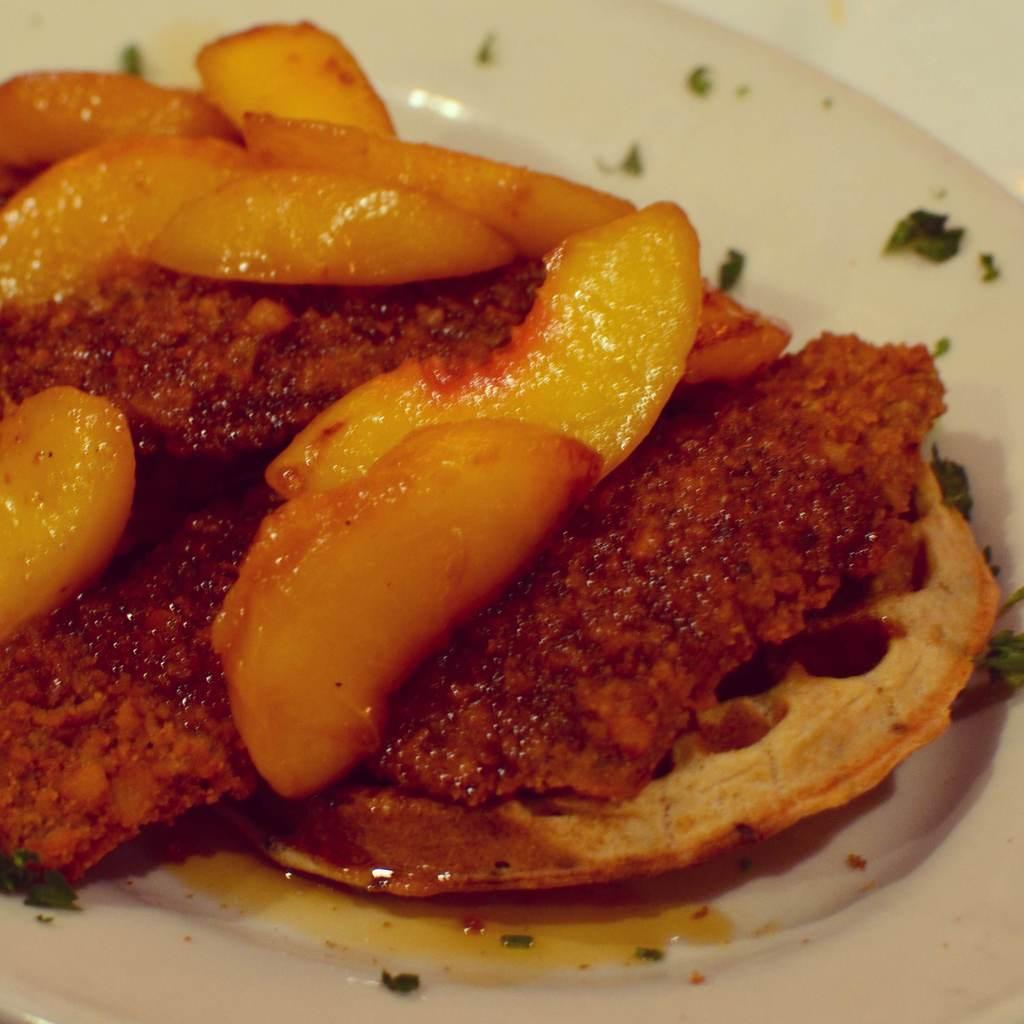What is the main subject of the image? The main subject of the image is food. How is the food presented in the image? The food is placed on a white plate. What type of lettuce is being used to promote peace in the image? There is no lettuce or reference to peace in the image; it only features food on a white plate. 